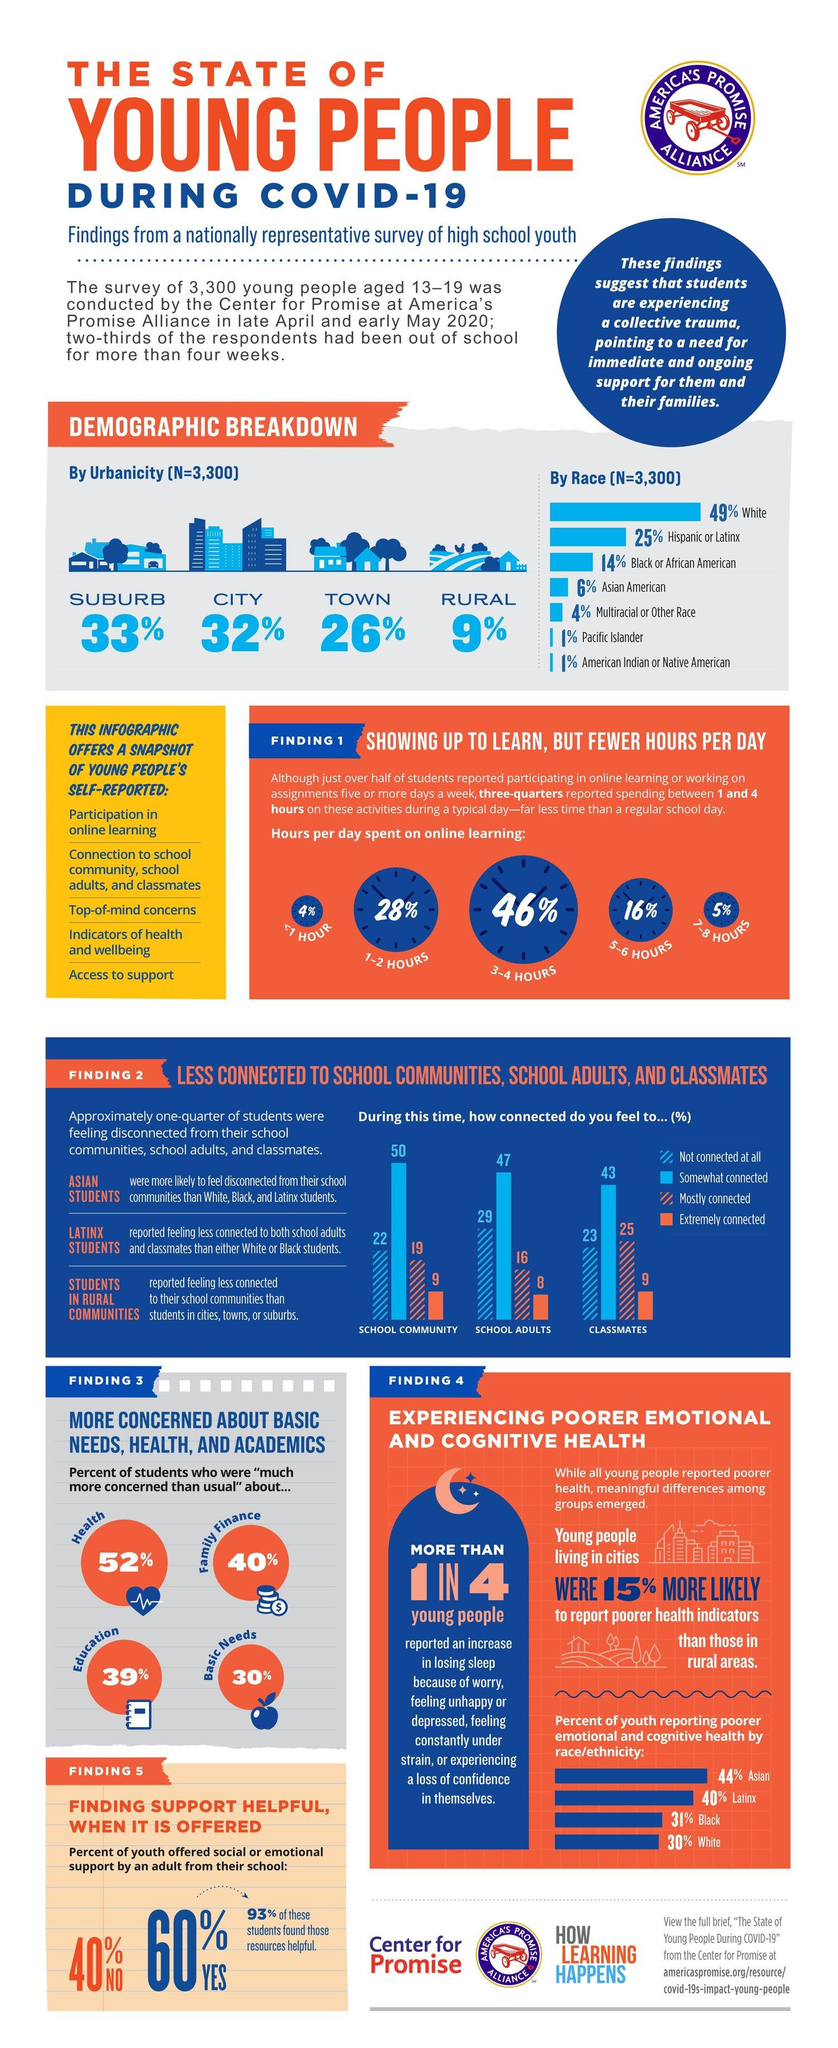Outline some significant characteristics in this image. According to a survey, 31% of black youths in America reported experiencing poorer emotional and cognitive health during the COVID-19 pandemic. A survey in America has revealed that 46% of students spend 3 to 4 hours per day on online learning during the COVID-19 pandemic. According to a survey, a small percentage of students in America, approximately 5%, reported spending 7-8 hours per day on online learning during the COVID-19 pandemic. According to a survey, 30% of students in America were significantly worried about their basic needs during the COVID-19 pandemic. According to a survey of students in America, 90% of them felt extremely connected to their classmates during the COVID-19 pandemic. 